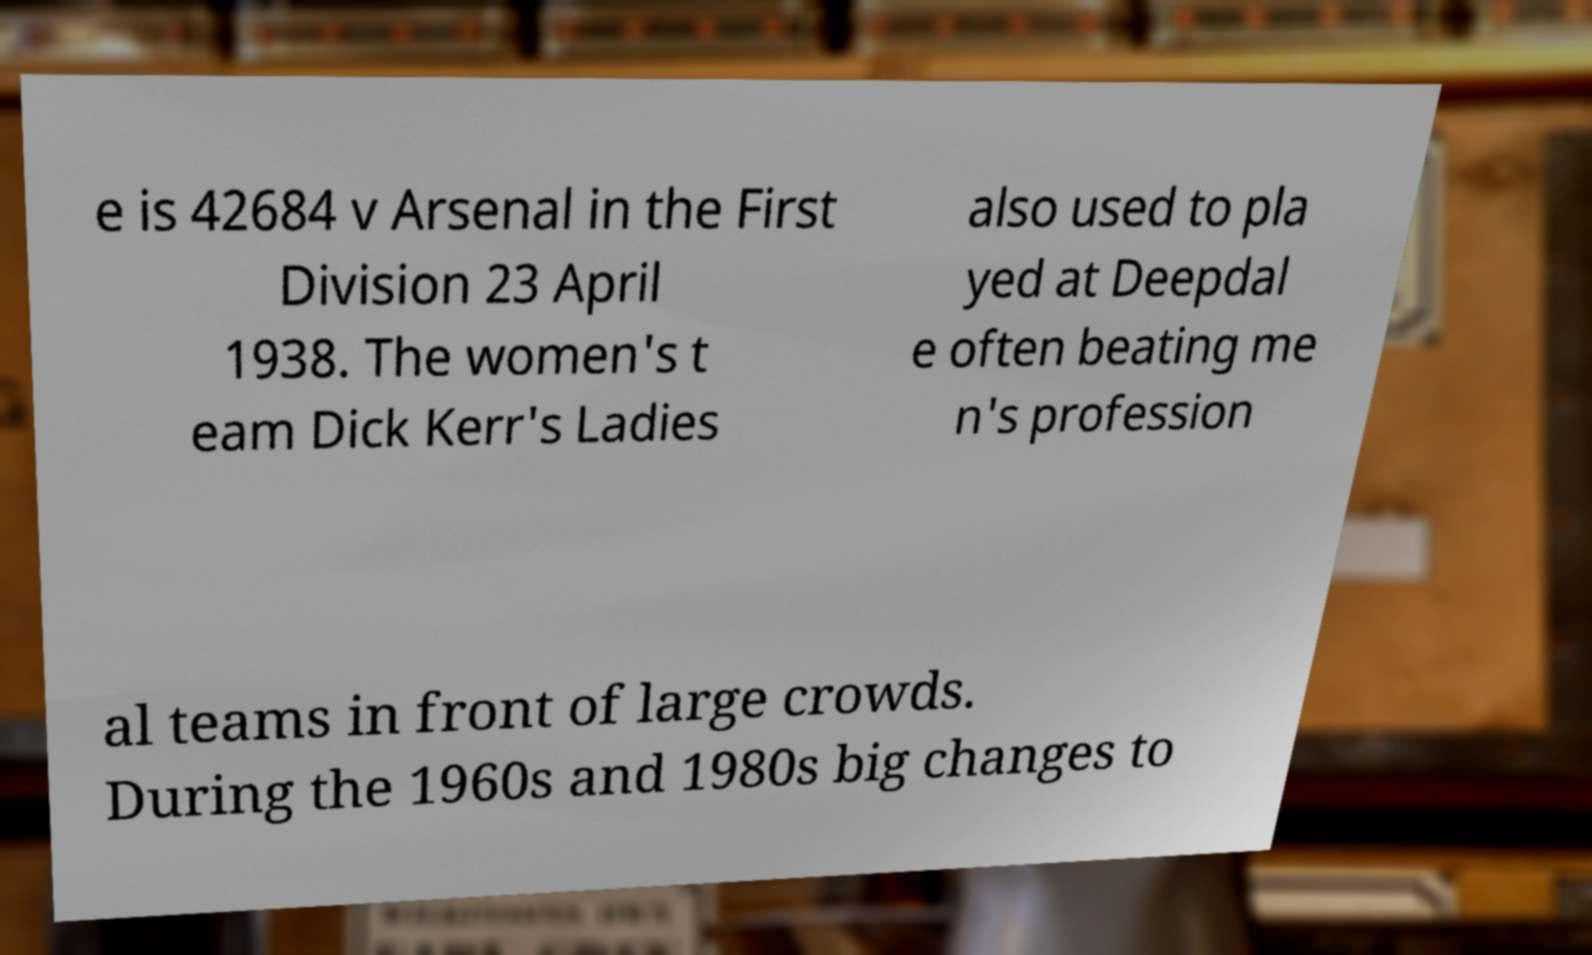Please read and relay the text visible in this image. What does it say? e is 42684 v Arsenal in the First Division 23 April 1938. The women's t eam Dick Kerr's Ladies also used to pla yed at Deepdal e often beating me n's profession al teams in front of large crowds. During the 1960s and 1980s big changes to 